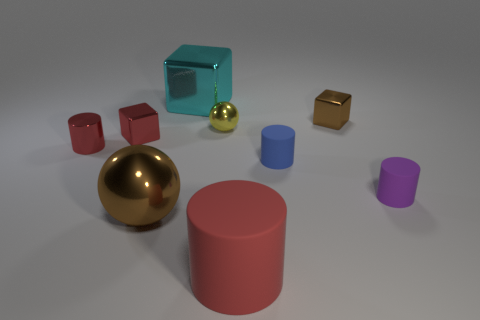Subtract all purple cylinders. How many cylinders are left? 3 Subtract all cyan cylinders. Subtract all purple balls. How many cylinders are left? 4 Add 1 red cubes. How many objects exist? 10 Subtract all cubes. How many objects are left? 6 Add 8 red matte things. How many red matte things exist? 9 Subtract 1 brown blocks. How many objects are left? 8 Subtract all brown spheres. Subtract all cyan metallic objects. How many objects are left? 7 Add 1 blue objects. How many blue objects are left? 2 